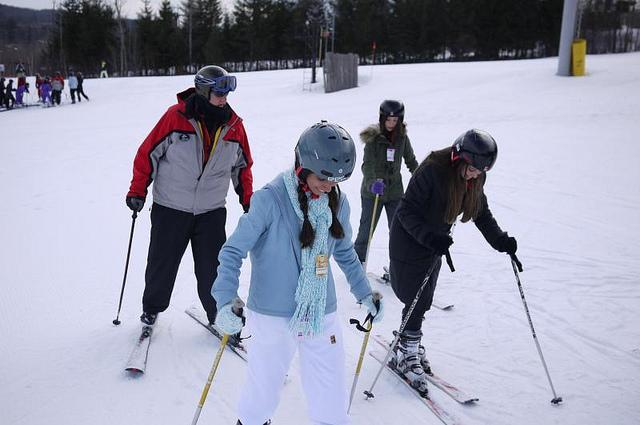What is this group ready to do? Please explain your reasoning. descend. The group is at the bottom of a relatively flat area.  they are wearing skis and look prepared to go skiing. 